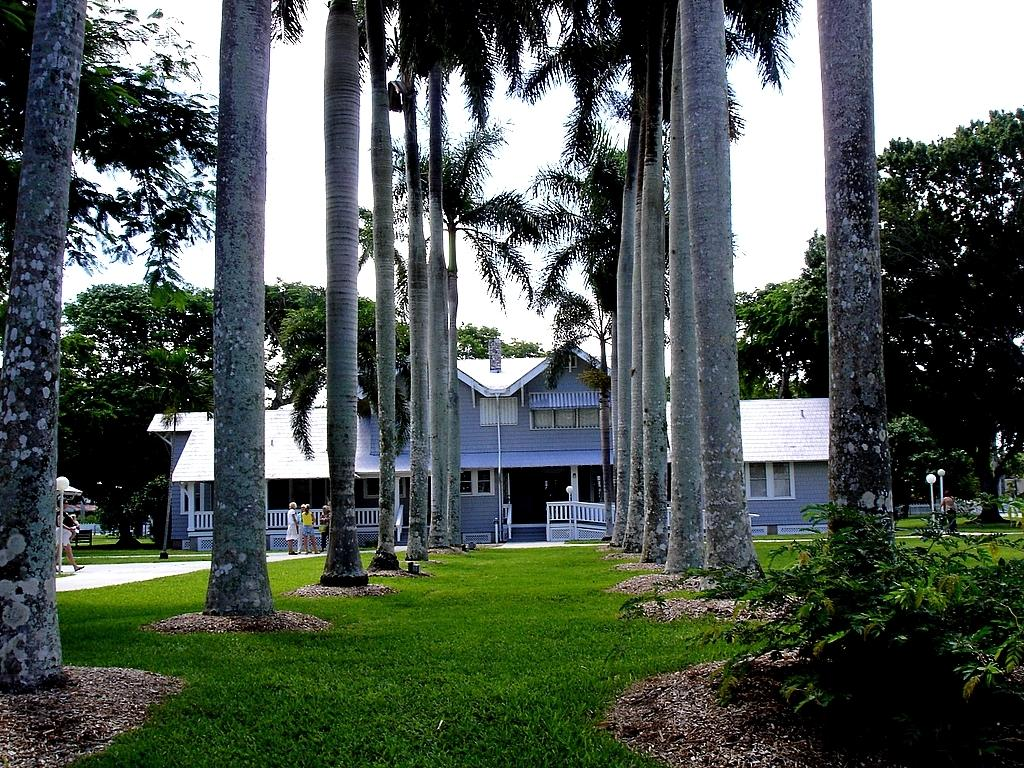How many people are in the image? There are people in the image, but the exact number is not specified. What type of structure is present in the image? There is a house in the image. What is used to enclose the area around the house? There is fencing in the image. What type of ground is visible in the image? The ground with grass is visible in the image. What are the poles used for in the image? The purpose of the poles in the image is not specified. What type of vegetation is present in the image? There are plants and trees in the image. What type of lighting is present in the image? There are lights in the image. What part of the natural environment is visible in the image? The sky is visible in the image. What type of breakfast is being served in the image? There is no breakfast present in the image. How comfortable are the people sitting on the grass in the image? The comfort level of the people sitting on the grass is not mentioned in the image. 